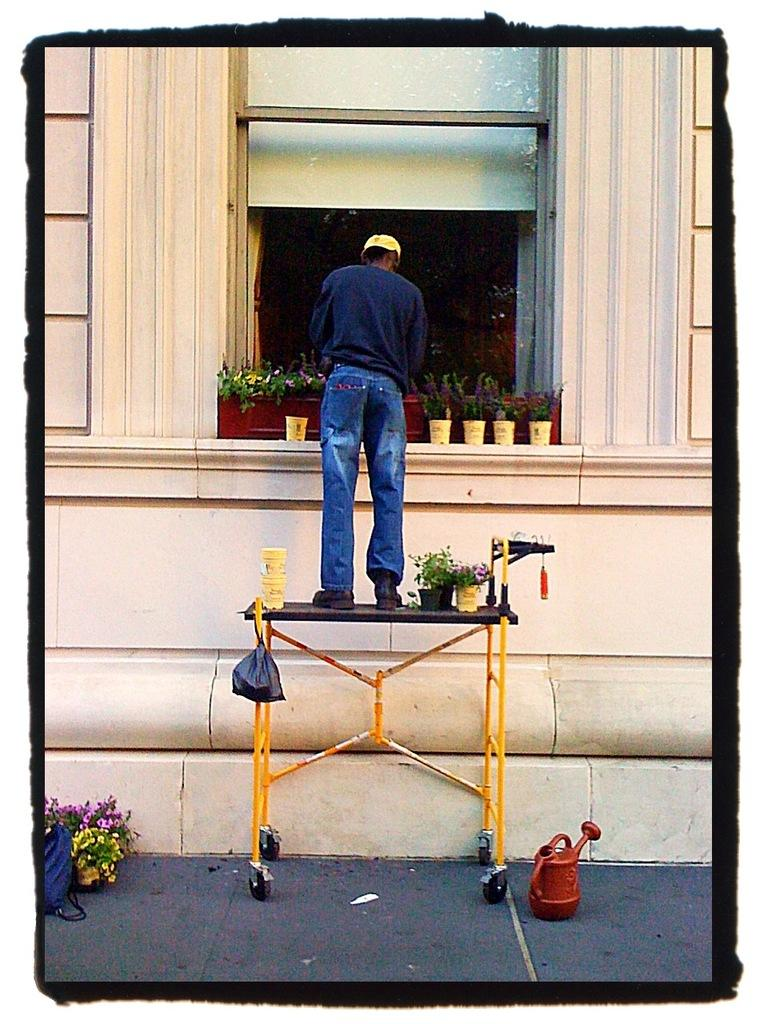Who is present in the image? There is a man in the image. What is the man doing in the image? The man is standing on a stand in the image. What can be seen on the ground in the image? There are small plants and flowers on the ground in the image. What is the shape of the fifth flower in the image? There is no mention of a specific number of flowers in the image, so it is impossible to determine the shape of the fifth flower. 